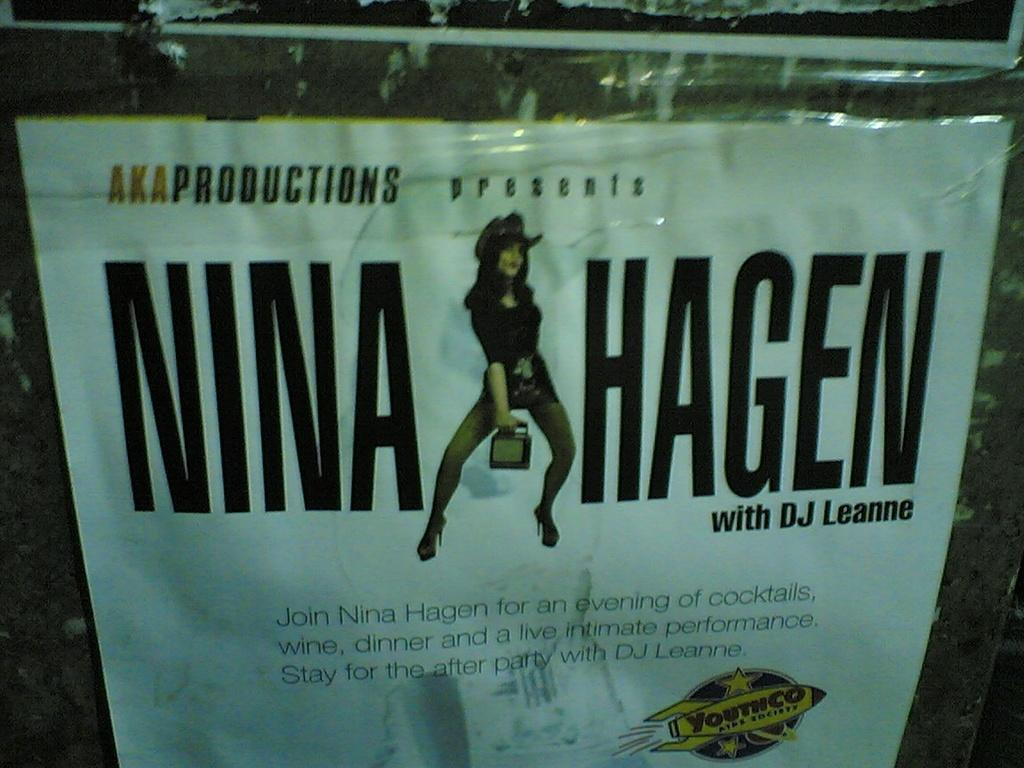What is present in the image that features a visual representation? There is a poster in the image. What is depicted on the poster? The poster contains a picture of a lady. Are there any words or phrases on the poster? Yes, there are texts on the poster. What type of club is the lady holding in the image? There is no club present in the image; the lady is depicted on the poster, not holding any object. 